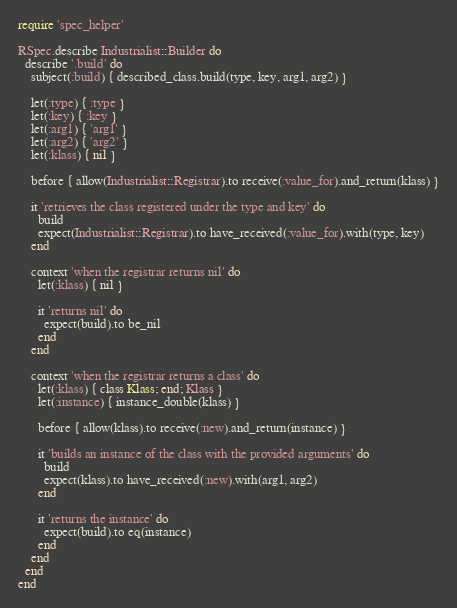Convert code to text. <code><loc_0><loc_0><loc_500><loc_500><_Ruby_>require 'spec_helper'

RSpec.describe Industrialist::Builder do
  describe '.build' do
    subject(:build) { described_class.build(type, key, arg1, arg2) }

    let(:type) { :type }
    let(:key) { :key }
    let(:arg1) { 'arg1' }
    let(:arg2) { 'arg2' }
    let(:klass) { nil }

    before { allow(Industrialist::Registrar).to receive(:value_for).and_return(klass) }

    it 'retrieves the class registered under the type and key' do
      build
      expect(Industrialist::Registrar).to have_received(:value_for).with(type, key)
    end

    context 'when the registrar returns nil' do
      let(:klass) { nil }

      it 'returns nil' do
        expect(build).to be_nil
      end
    end

    context 'when the registrar returns a class' do
      let(:klass) { class Klass; end; Klass }
      let(:instance) { instance_double(klass) }

      before { allow(klass).to receive(:new).and_return(instance) }

      it 'builds an instance of the class with the provided arguments' do
        build
        expect(klass).to have_received(:new).with(arg1, arg2)
      end

      it 'returns the instance' do
        expect(build).to eq(instance)
      end
    end
  end
end
</code> 